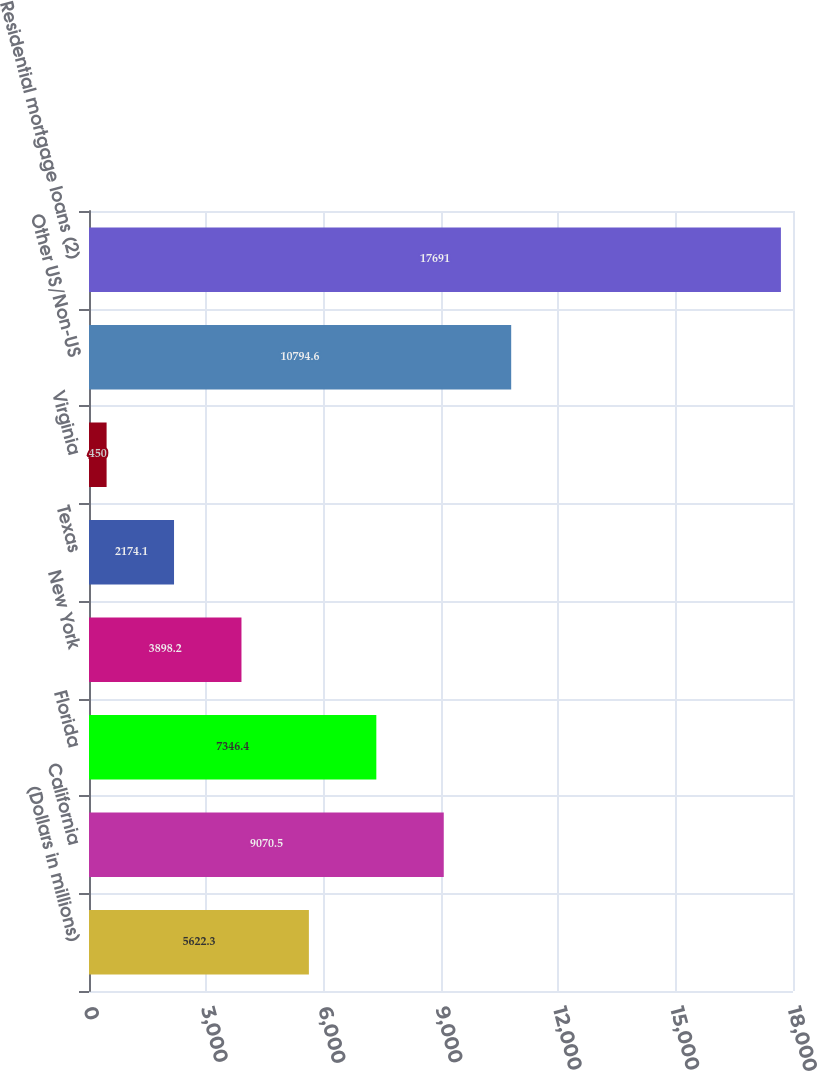Convert chart to OTSL. <chart><loc_0><loc_0><loc_500><loc_500><bar_chart><fcel>(Dollars in millions)<fcel>California<fcel>Florida<fcel>New York<fcel>Texas<fcel>Virginia<fcel>Other US/Non-US<fcel>Residential mortgage loans (2)<nl><fcel>5622.3<fcel>9070.5<fcel>7346.4<fcel>3898.2<fcel>2174.1<fcel>450<fcel>10794.6<fcel>17691<nl></chart> 